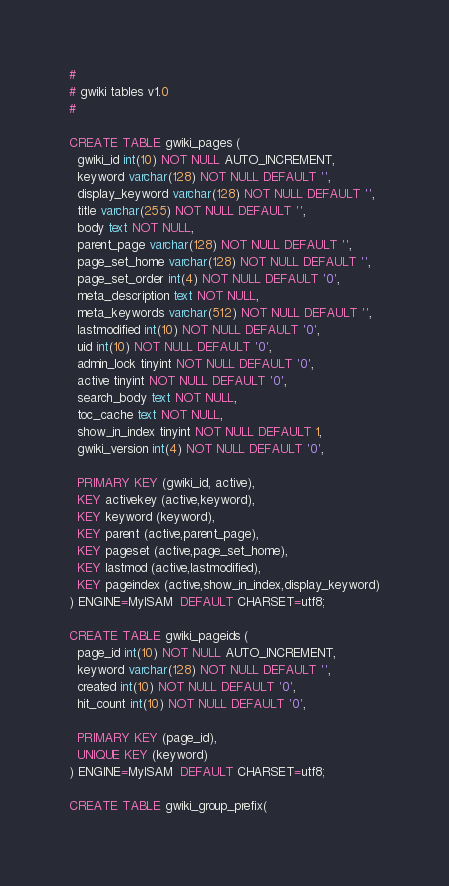Convert code to text. <code><loc_0><loc_0><loc_500><loc_500><_SQL_>#
# gwiki tables v1.0
#

CREATE TABLE gwiki_pages (
  gwiki_id int(10) NOT NULL AUTO_INCREMENT,
  keyword varchar(128) NOT NULL DEFAULT '',
  display_keyword varchar(128) NOT NULL DEFAULT '',
  title varchar(255) NOT NULL DEFAULT '',
  body text NOT NULL,
  parent_page varchar(128) NOT NULL DEFAULT '',
  page_set_home varchar(128) NOT NULL DEFAULT '',
  page_set_order int(4) NOT NULL DEFAULT '0',
  meta_description text NOT NULL,
  meta_keywords varchar(512) NOT NULL DEFAULT '',
  lastmodified int(10) NOT NULL DEFAULT '0',
  uid int(10) NOT NULL DEFAULT '0',
  admin_lock tinyint NOT NULL DEFAULT '0',
  active tinyint NOT NULL DEFAULT '0',
  search_body text NOT NULL,
  toc_cache text NOT NULL,
  show_in_index tinyint NOT NULL DEFAULT 1,
  gwiki_version int(4) NOT NULL DEFAULT '0',

  PRIMARY KEY (gwiki_id, active),
  KEY activekey (active,keyword),
  KEY keyword (keyword),
  KEY parent (active,parent_page),
  KEY pageset (active,page_set_home),
  KEY lastmod (active,lastmodified),
  KEY pageindex (active,show_in_index,display_keyword)
) ENGINE=MyISAM  DEFAULT CHARSET=utf8;

CREATE TABLE gwiki_pageids (
  page_id int(10) NOT NULL AUTO_INCREMENT,
  keyword varchar(128) NOT NULL DEFAULT '',
  created int(10) NOT NULL DEFAULT '0',
  hit_count int(10) NOT NULL DEFAULT '0',

  PRIMARY KEY (page_id),
  UNIQUE KEY (keyword)
) ENGINE=MyISAM  DEFAULT CHARSET=utf8;

CREATE TABLE gwiki_group_prefix(</code> 